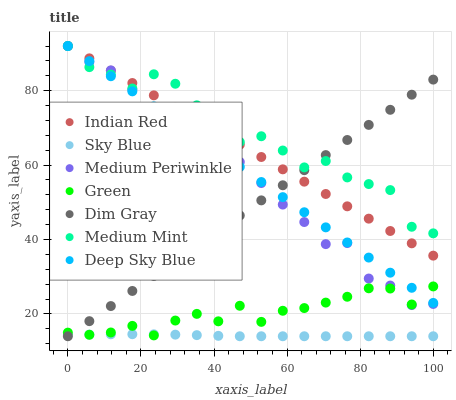Does Sky Blue have the minimum area under the curve?
Answer yes or no. Yes. Does Medium Mint have the maximum area under the curve?
Answer yes or no. Yes. Does Dim Gray have the minimum area under the curve?
Answer yes or no. No. Does Dim Gray have the maximum area under the curve?
Answer yes or no. No. Is Dim Gray the smoothest?
Answer yes or no. Yes. Is Medium Mint the roughest?
Answer yes or no. Yes. Is Deep Sky Blue the smoothest?
Answer yes or no. No. Is Deep Sky Blue the roughest?
Answer yes or no. No. Does Dim Gray have the lowest value?
Answer yes or no. Yes. Does Deep Sky Blue have the lowest value?
Answer yes or no. No. Does Indian Red have the highest value?
Answer yes or no. Yes. Does Dim Gray have the highest value?
Answer yes or no. No. Is Green less than Medium Mint?
Answer yes or no. Yes. Is Deep Sky Blue greater than Sky Blue?
Answer yes or no. Yes. Does Deep Sky Blue intersect Dim Gray?
Answer yes or no. Yes. Is Deep Sky Blue less than Dim Gray?
Answer yes or no. No. Is Deep Sky Blue greater than Dim Gray?
Answer yes or no. No. Does Green intersect Medium Mint?
Answer yes or no. No. 